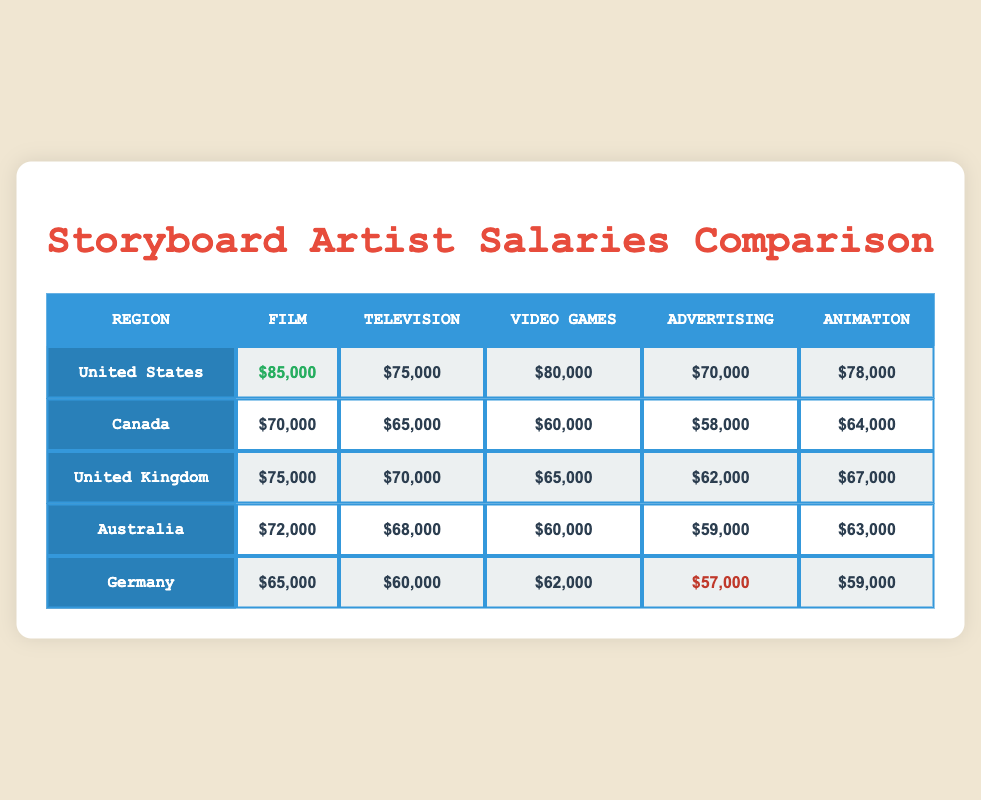What is the highest salary for storyboard artists in the United States? The highest salary for storyboard artists in the United States can be found in the Film category, which is listed as $85,000 in the table for that region.
Answer: $85,000 Which region pays the lowest for storyboard artists in the Advertising industry? In the Advertising category, Germany pays the lowest salary, listed as $57,000, compared to the other regions.
Answer: Germany What is the average salary of storyboard artists in Canada across all industries? To calculate the average salary for Canada, we sum the salaries in all industries: (70,000 + 65,000 + 60,000 + 58,000 + 64,000) = 317,000. Then, divide by the number of industries (5): 317,000 / 5 = 63,400.
Answer: 63,400 Is the salary for storyboard artists in Video Games in Australia higher than in the United Kingdom? In the Video Games category, Australia's salary is $60,000 while the UK's salary is $65,000. Since $60,000 is lower than $65,000, the statement is false.
Answer: No If you look at the Animation industry salaries, which region has the highest pay? The Animation category shows that the United States has the highest pay at $78,000 compared to the other regions (Canada: $64,000, United Kingdom: $67,000, Australia: $63,000, Germany: $59,000).
Answer: United States What is the difference in salary for storyboard artists in Film between the United States and Germany? The salary for Film in the United States is $85,000, and in Germany, it is $65,000. The difference is calculated as $85,000 - $65,000 = $20,000.
Answer: $20,000 Which industry has the least variation in storyboard artist salaries across the five regions? To determine this, we compare the range of salaries for each industry. The Animation industry ranges from $59,000 (Germany) to $78,000 (United States), which is $19,000. Advertising has a range of $57,000 to $70,000, totaling $13,000, showing that Advertising has the least variation.
Answer: Advertising Is the average salary for storyboard artists in Television higher in Canada compared to Germany? The average salary for Television in Canada is $65,000, while in Germany, it is $60,000. Since $65,000 is higher than $60,000, the statement is true.
Answer: Yes What are the employment trends for storyboard artists in the Video Games industry in Australia and Canada? Salaries for storyboard artists in Video Games are $60,000 in Australia and $60,000 in Canada, indicating that both regions have the same pay for this category. Their trends would reflect equal compensation in the industry.
Answer: Same pay 